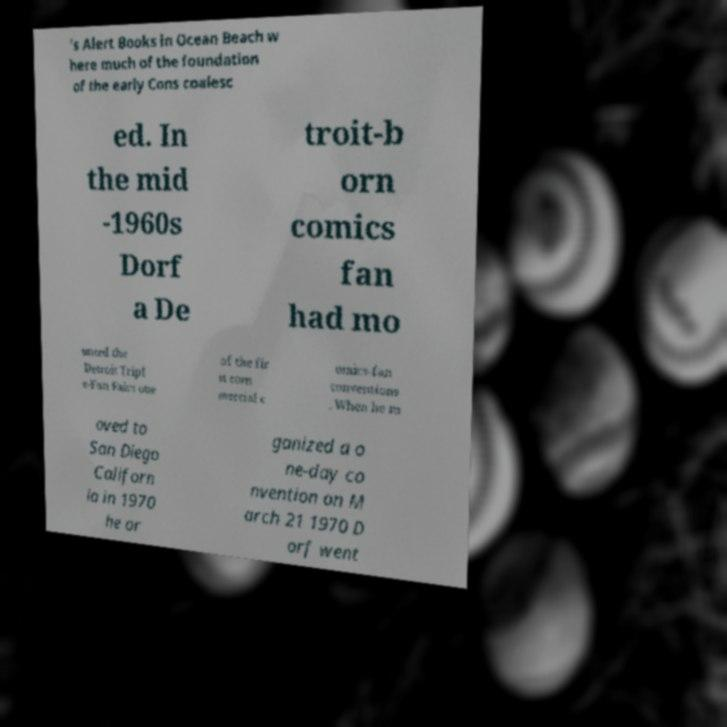For documentation purposes, I need the text within this image transcribed. Could you provide that? 's Alert Books in Ocean Beach w here much of the foundation of the early Cons coalesc ed. In the mid -1960s Dorf a De troit-b orn comics fan had mo unted the Detroit Tripl e-Fan Fairs one of the fir st com mercial c omics-fan conventions . When he m oved to San Diego Californ ia in 1970 he or ganized a o ne-day co nvention on M arch 21 1970 D orf went 